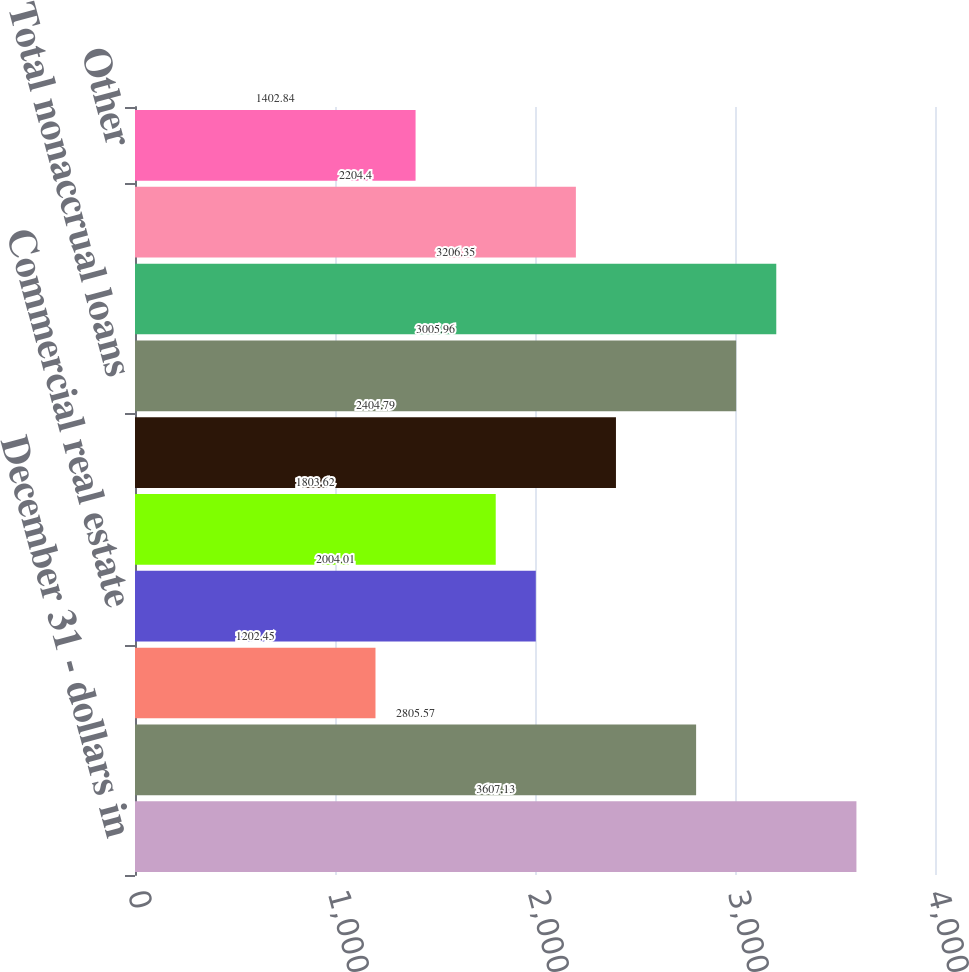Convert chart to OTSL. <chart><loc_0><loc_0><loc_500><loc_500><bar_chart><fcel>December 31 - dollars in<fcel>Commercial<fcel>Lease financing<fcel>Commercial real estate<fcel>Consumer<fcel>Residential mortgage<fcel>Total nonaccrual loans<fcel>Total nonperforming loans<fcel>Lease<fcel>Other<nl><fcel>3607.13<fcel>2805.57<fcel>1202.45<fcel>2004.01<fcel>1803.62<fcel>2404.79<fcel>3005.96<fcel>3206.35<fcel>2204.4<fcel>1402.84<nl></chart> 